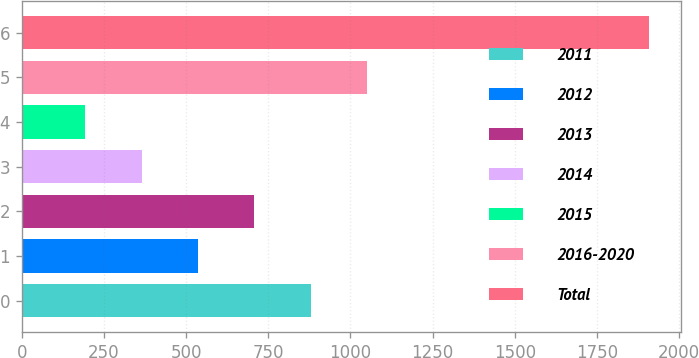Convert chart. <chart><loc_0><loc_0><loc_500><loc_500><bar_chart><fcel>2011<fcel>2012<fcel>2013<fcel>2014<fcel>2015<fcel>2016-2020<fcel>Total<nl><fcel>879.4<fcel>536.2<fcel>707.8<fcel>364.6<fcel>193<fcel>1051<fcel>1909<nl></chart> 